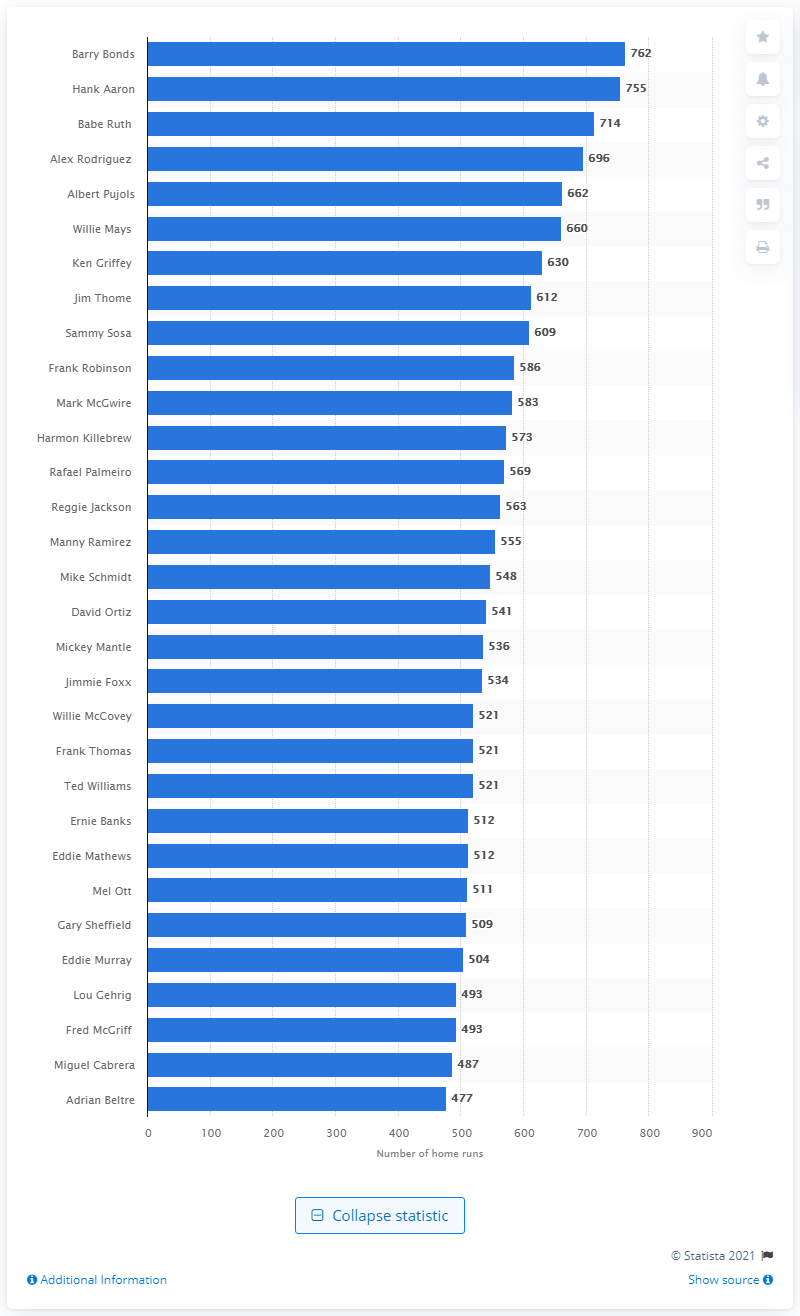Specify some key components in this picture. During the time period between 1986 and 2007, Barry Bonds hit a total of 762 home runs. 